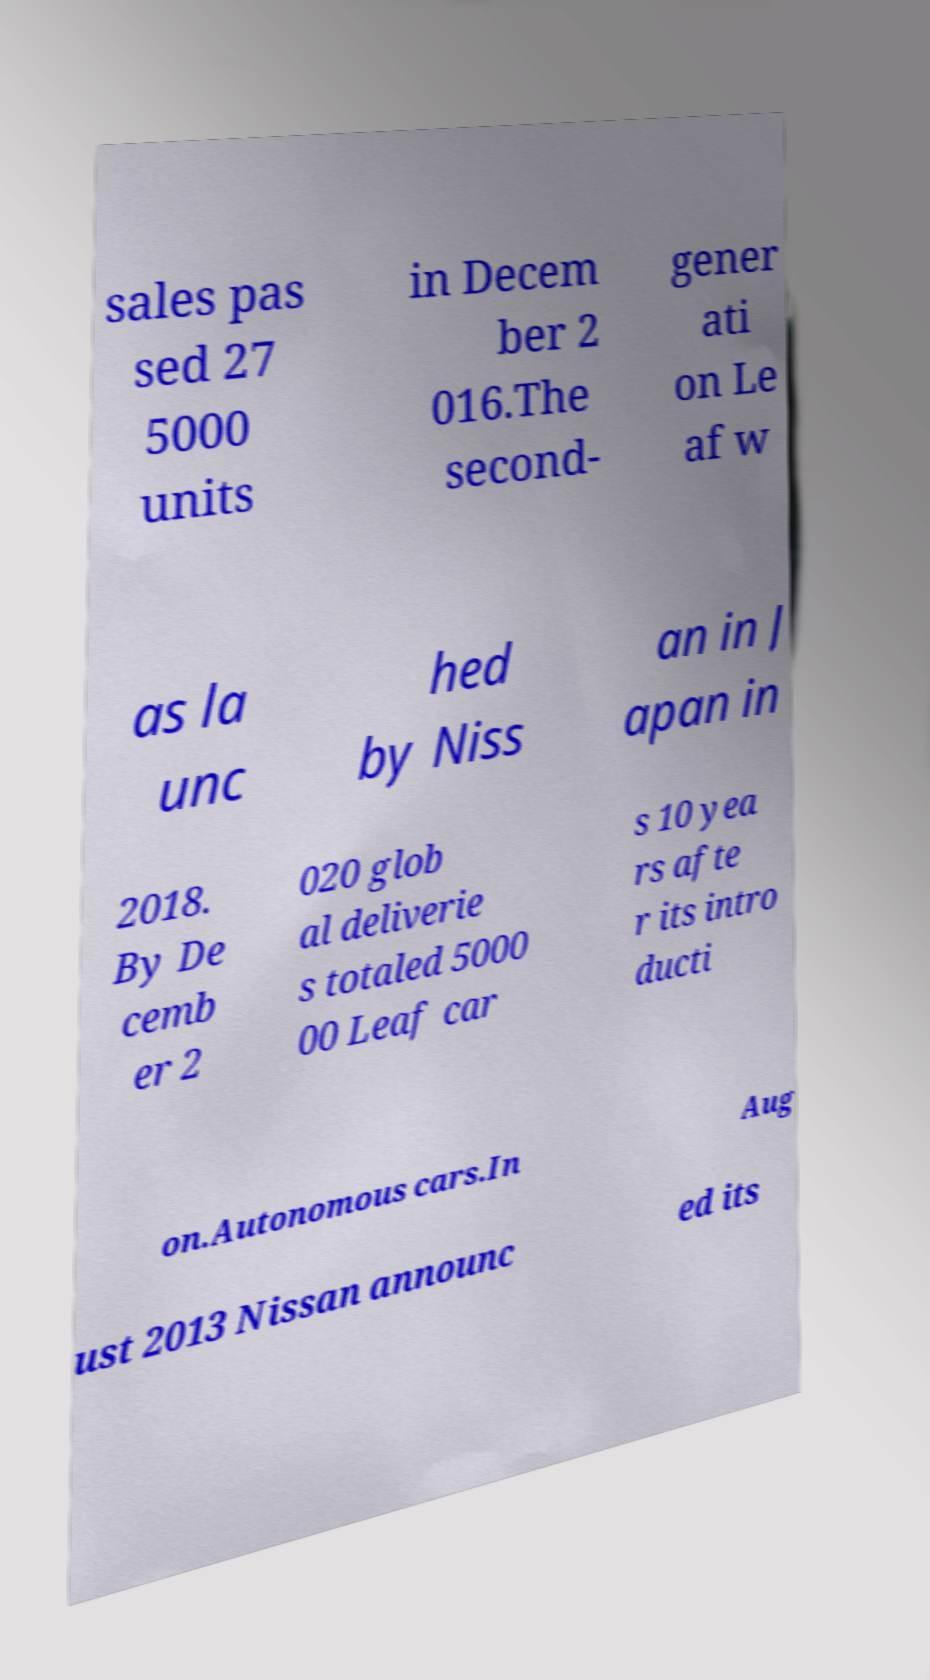Please read and relay the text visible in this image. What does it say? sales pas sed 27 5000 units in Decem ber 2 016.The second- gener ati on Le af w as la unc hed by Niss an in J apan in 2018. By De cemb er 2 020 glob al deliverie s totaled 5000 00 Leaf car s 10 yea rs afte r its intro ducti on.Autonomous cars.In Aug ust 2013 Nissan announc ed its 